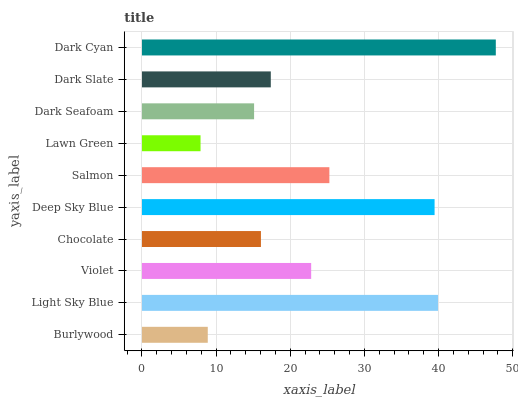Is Lawn Green the minimum?
Answer yes or no. Yes. Is Dark Cyan the maximum?
Answer yes or no. Yes. Is Light Sky Blue the minimum?
Answer yes or no. No. Is Light Sky Blue the maximum?
Answer yes or no. No. Is Light Sky Blue greater than Burlywood?
Answer yes or no. Yes. Is Burlywood less than Light Sky Blue?
Answer yes or no. Yes. Is Burlywood greater than Light Sky Blue?
Answer yes or no. No. Is Light Sky Blue less than Burlywood?
Answer yes or no. No. Is Violet the high median?
Answer yes or no. Yes. Is Dark Slate the low median?
Answer yes or no. Yes. Is Dark Seafoam the high median?
Answer yes or no. No. Is Dark Cyan the low median?
Answer yes or no. No. 